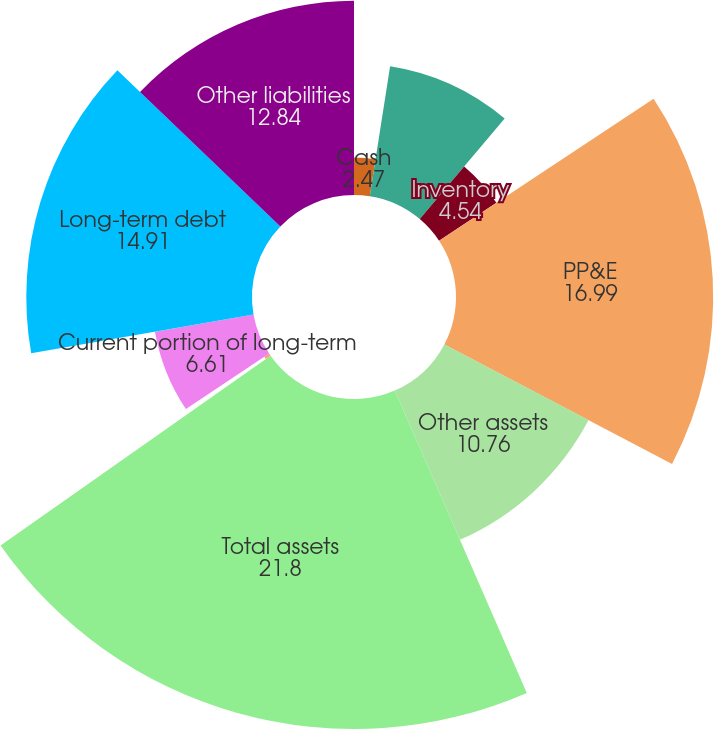Convert chart. <chart><loc_0><loc_0><loc_500><loc_500><pie_chart><fcel>Cash<fcel>Accounts receivable net<fcel>Inventory<fcel>PP&E<fcel>Other assets<fcel>Total assets<fcel>Accounts payable<fcel>Current portion of long-term<fcel>Long-term debt<fcel>Other liabilities<nl><fcel>2.47%<fcel>8.69%<fcel>4.54%<fcel>16.99%<fcel>10.76%<fcel>21.8%<fcel>0.39%<fcel>6.61%<fcel>14.91%<fcel>12.84%<nl></chart> 